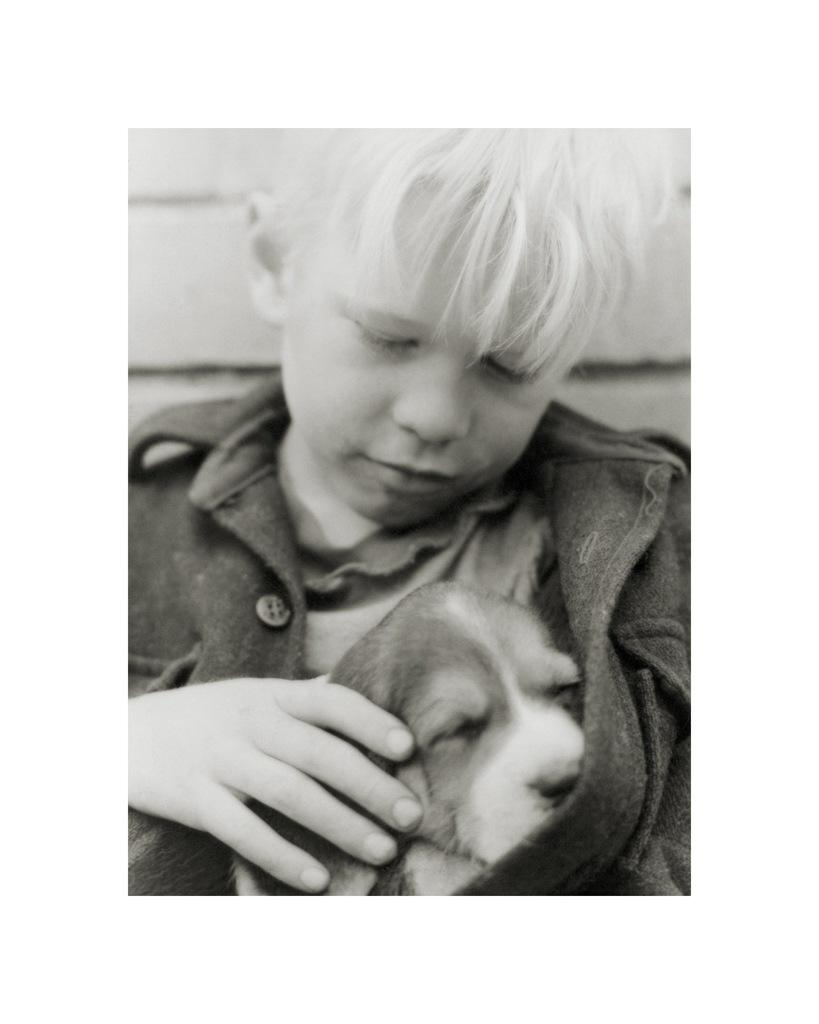Who is the main subject in the image? There is a boy in the image. What is the boy wearing? The boy is wearing a black jacket. What is the boy holding in the image? The boy is holding a dog. What can be seen in the background of the image? There is a wall in the background of the image. What type of art is the boy drawing in the image? There is no art or drawing activity present in the image; the boy is holding a dog. 